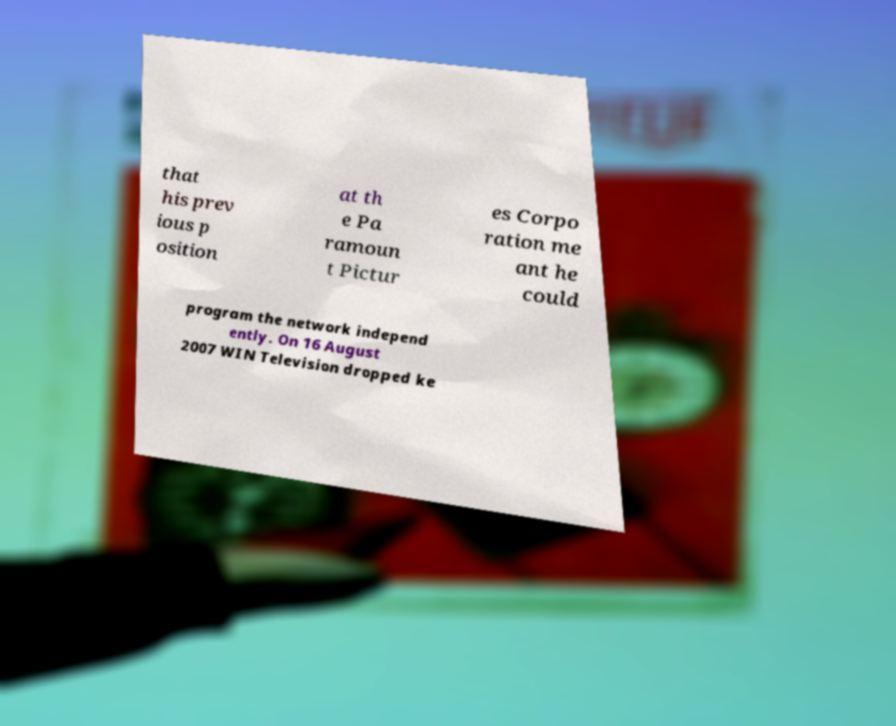Please read and relay the text visible in this image. What does it say? that his prev ious p osition at th e Pa ramoun t Pictur es Corpo ration me ant he could program the network independ ently. On 16 August 2007 WIN Television dropped ke 